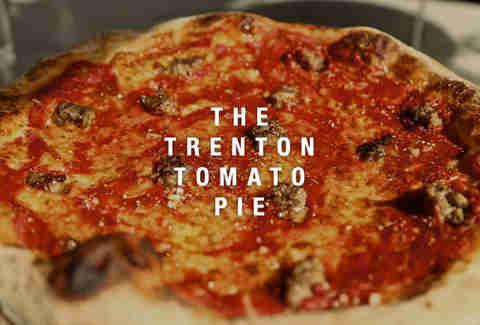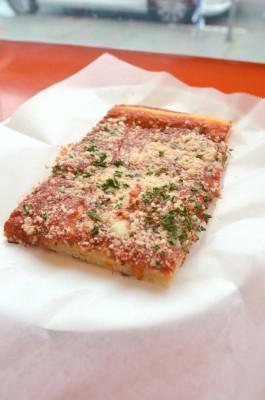The first image is the image on the left, the second image is the image on the right. Given the left and right images, does the statement "The left image shows at least one single slice of pizza." hold true? Answer yes or no. No. The first image is the image on the left, the second image is the image on the right. Examine the images to the left and right. Is the description "The right image contains a sliced round pizza with no slices missing, and the left image contains at least one wedge-shaped slice of pizza on white paper." accurate? Answer yes or no. No. 